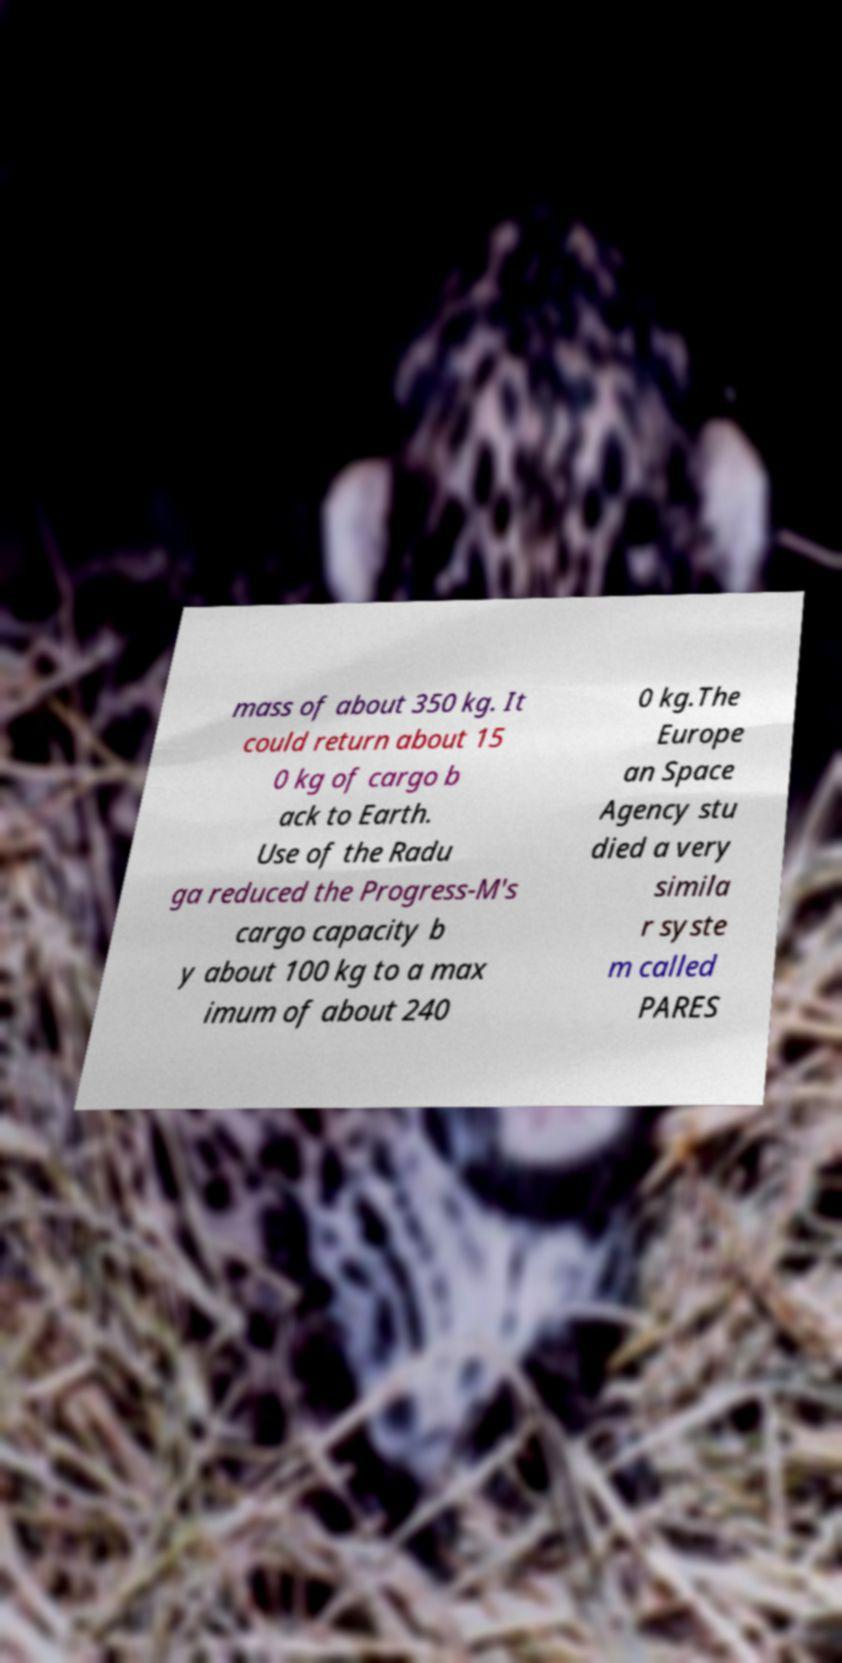What messages or text are displayed in this image? I need them in a readable, typed format. mass of about 350 kg. It could return about 15 0 kg of cargo b ack to Earth. Use of the Radu ga reduced the Progress-M's cargo capacity b y about 100 kg to a max imum of about 240 0 kg.The Europe an Space Agency stu died a very simila r syste m called PARES 